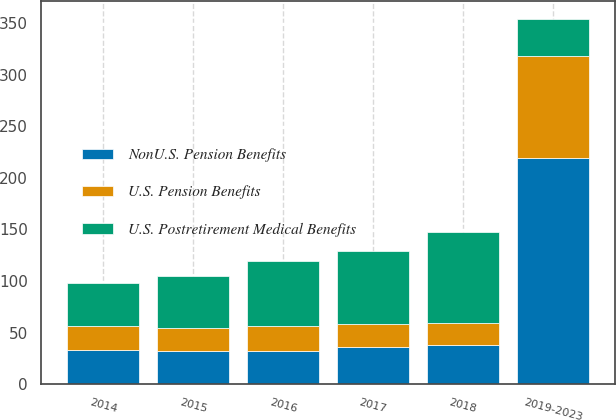<chart> <loc_0><loc_0><loc_500><loc_500><stacked_bar_chart><ecel><fcel>2014<fcel>2015<fcel>2016<fcel>2017<fcel>2018<fcel>2019-2023<nl><fcel>U.S. Postretirement Medical Benefits<fcel>42<fcel>51<fcel>63<fcel>71<fcel>88<fcel>36<nl><fcel>NonU.S. Pension Benefits<fcel>33<fcel>32<fcel>32<fcel>36<fcel>38<fcel>219<nl><fcel>U.S. Pension Benefits<fcel>23<fcel>22<fcel>24<fcel>22<fcel>21<fcel>99<nl></chart> 